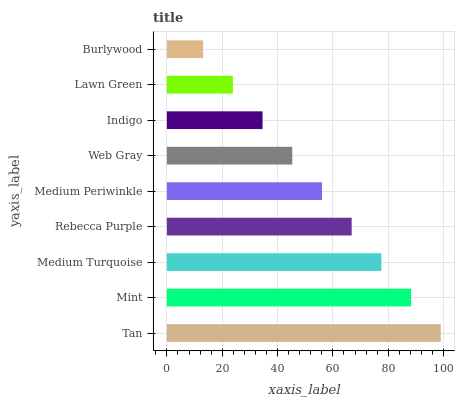Is Burlywood the minimum?
Answer yes or no. Yes. Is Tan the maximum?
Answer yes or no. Yes. Is Mint the minimum?
Answer yes or no. No. Is Mint the maximum?
Answer yes or no. No. Is Tan greater than Mint?
Answer yes or no. Yes. Is Mint less than Tan?
Answer yes or no. Yes. Is Mint greater than Tan?
Answer yes or no. No. Is Tan less than Mint?
Answer yes or no. No. Is Medium Periwinkle the high median?
Answer yes or no. Yes. Is Medium Periwinkle the low median?
Answer yes or no. Yes. Is Web Gray the high median?
Answer yes or no. No. Is Indigo the low median?
Answer yes or no. No. 